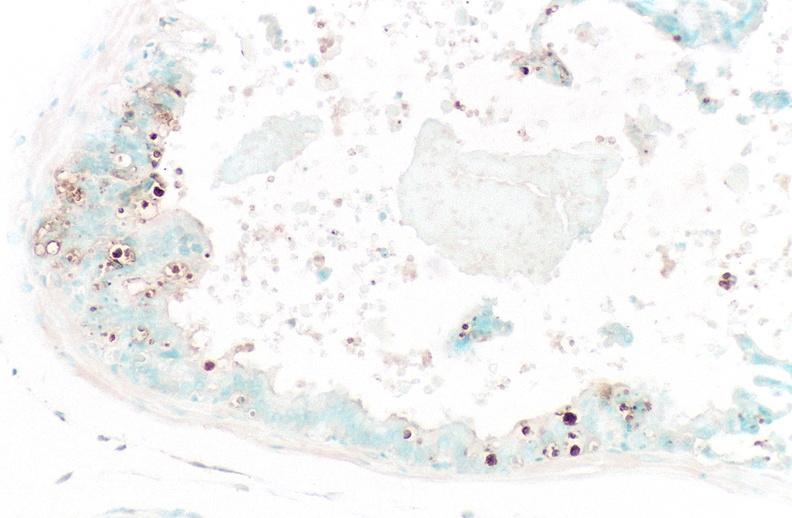do apoptosis tunel stain?
Answer the question using a single word or phrase. Yes 